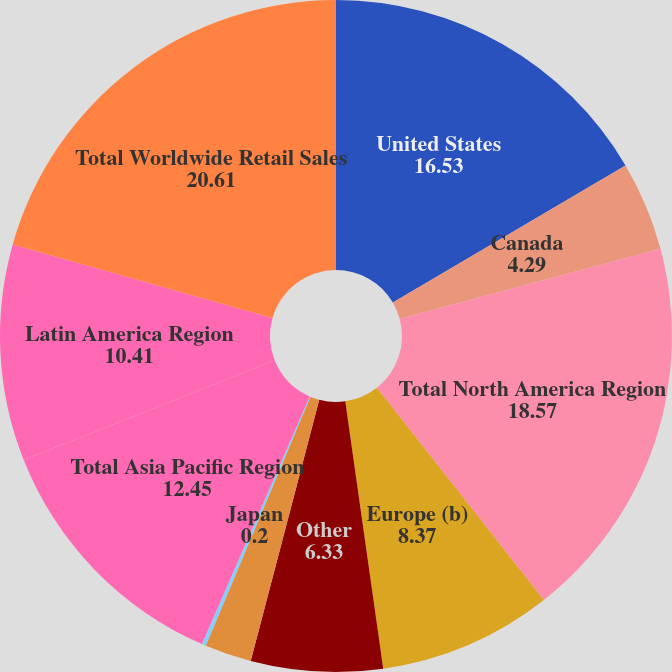Convert chart. <chart><loc_0><loc_0><loc_500><loc_500><pie_chart><fcel>United States<fcel>Canada<fcel>Total North America Region<fcel>Europe (b)<fcel>Other<fcel>Total EMEA Region<fcel>Japan<fcel>Total Asia Pacific Region<fcel>Latin America Region<fcel>Total Worldwide Retail Sales<nl><fcel>16.53%<fcel>4.29%<fcel>18.57%<fcel>8.37%<fcel>6.33%<fcel>2.25%<fcel>0.2%<fcel>12.45%<fcel>10.41%<fcel>20.61%<nl></chart> 